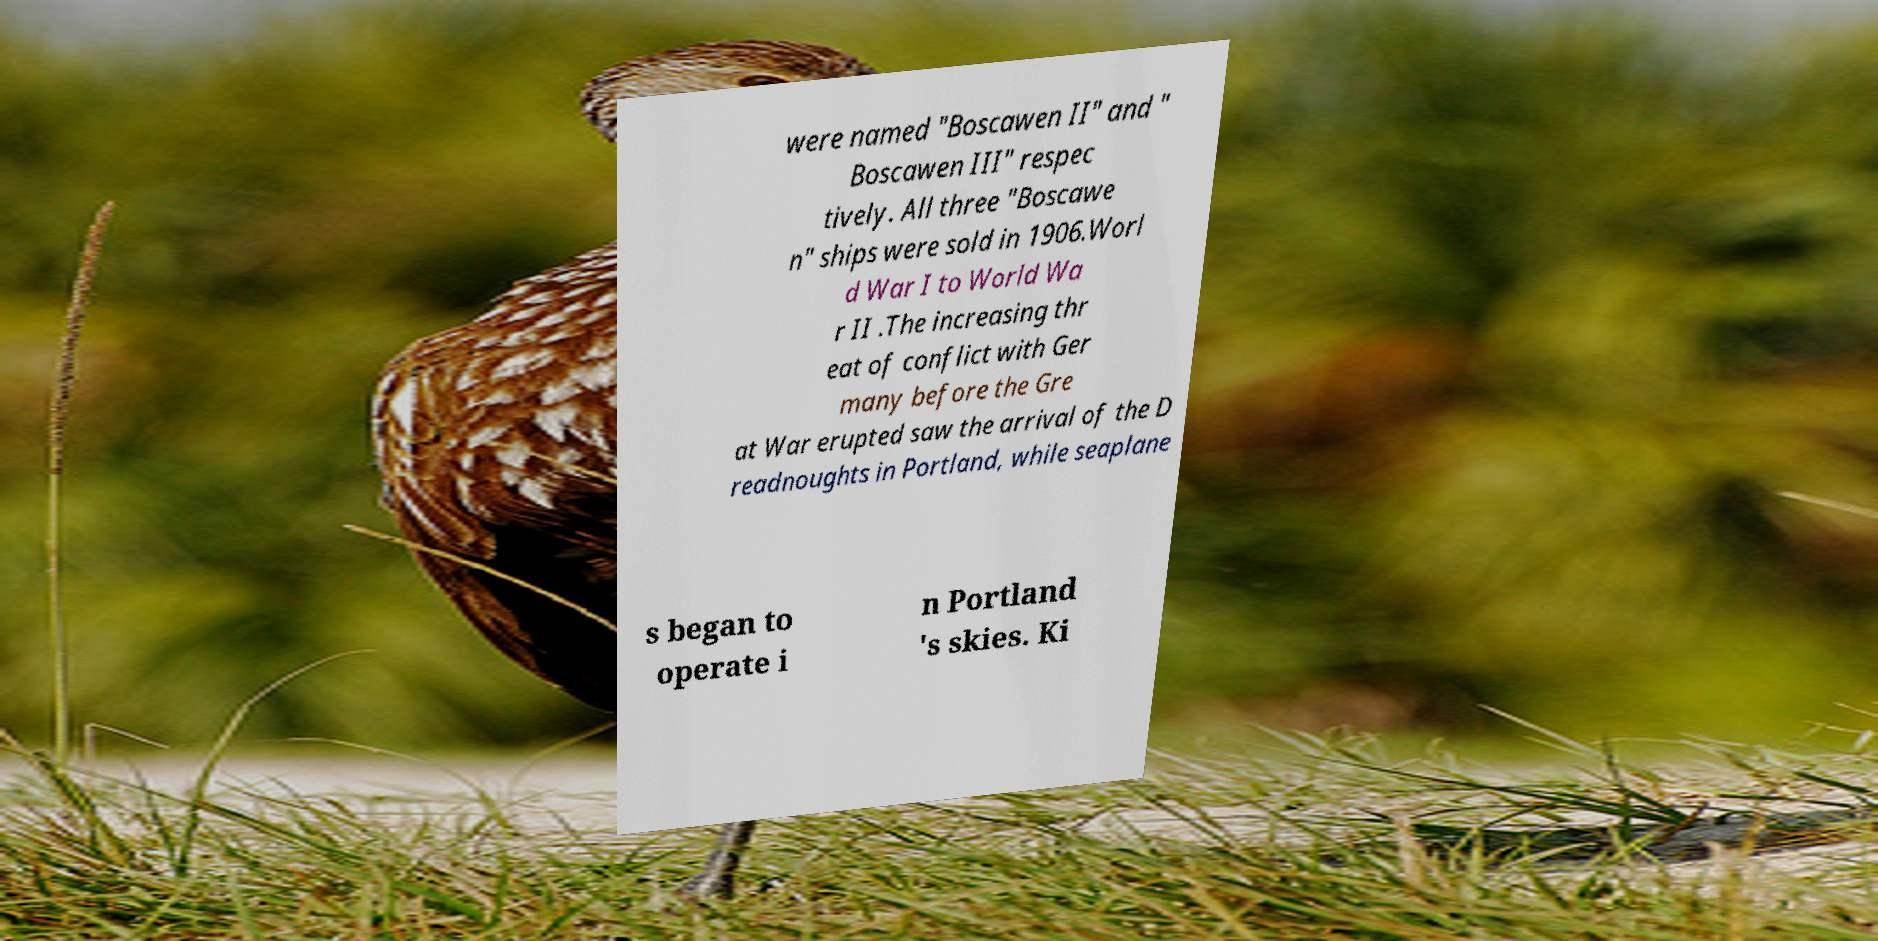Could you extract and type out the text from this image? were named "Boscawen II" and " Boscawen III" respec tively. All three "Boscawe n" ships were sold in 1906.Worl d War I to World Wa r II .The increasing thr eat of conflict with Ger many before the Gre at War erupted saw the arrival of the D readnoughts in Portland, while seaplane s began to operate i n Portland 's skies. Ki 